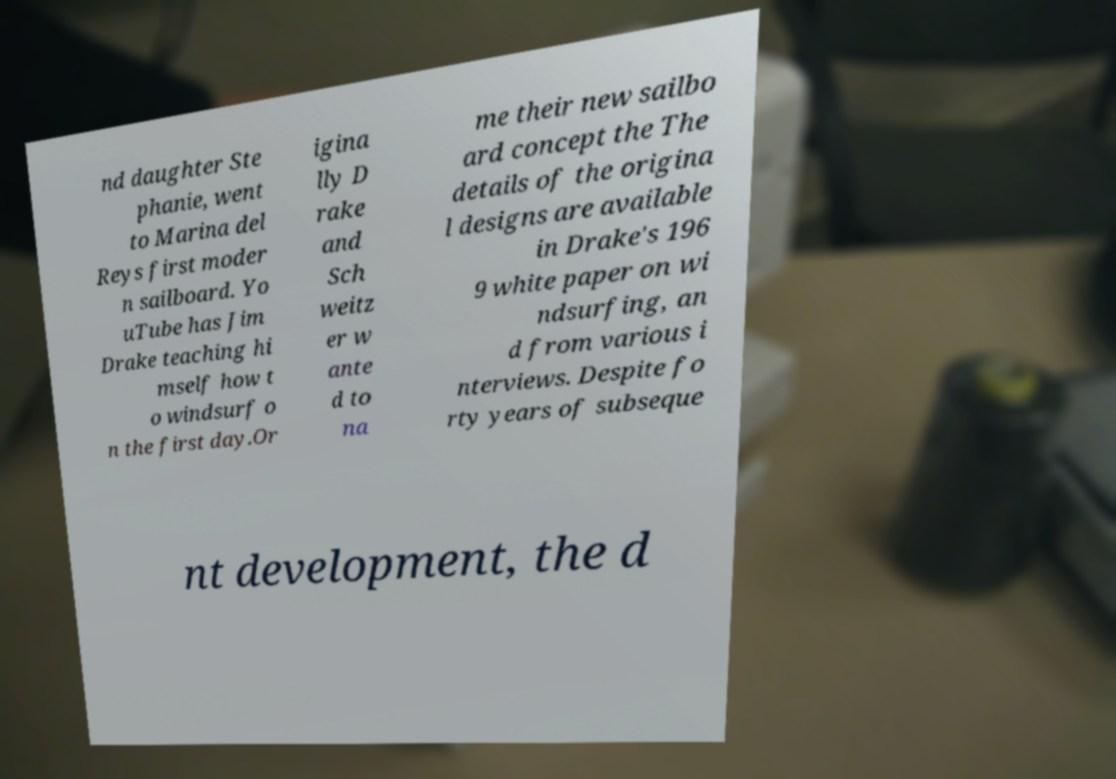I need the written content from this picture converted into text. Can you do that? nd daughter Ste phanie, went to Marina del Reys first moder n sailboard. Yo uTube has Jim Drake teaching hi mself how t o windsurf o n the first day.Or igina lly D rake and Sch weitz er w ante d to na me their new sailbo ard concept the The details of the origina l designs are available in Drake's 196 9 white paper on wi ndsurfing, an d from various i nterviews. Despite fo rty years of subseque nt development, the d 